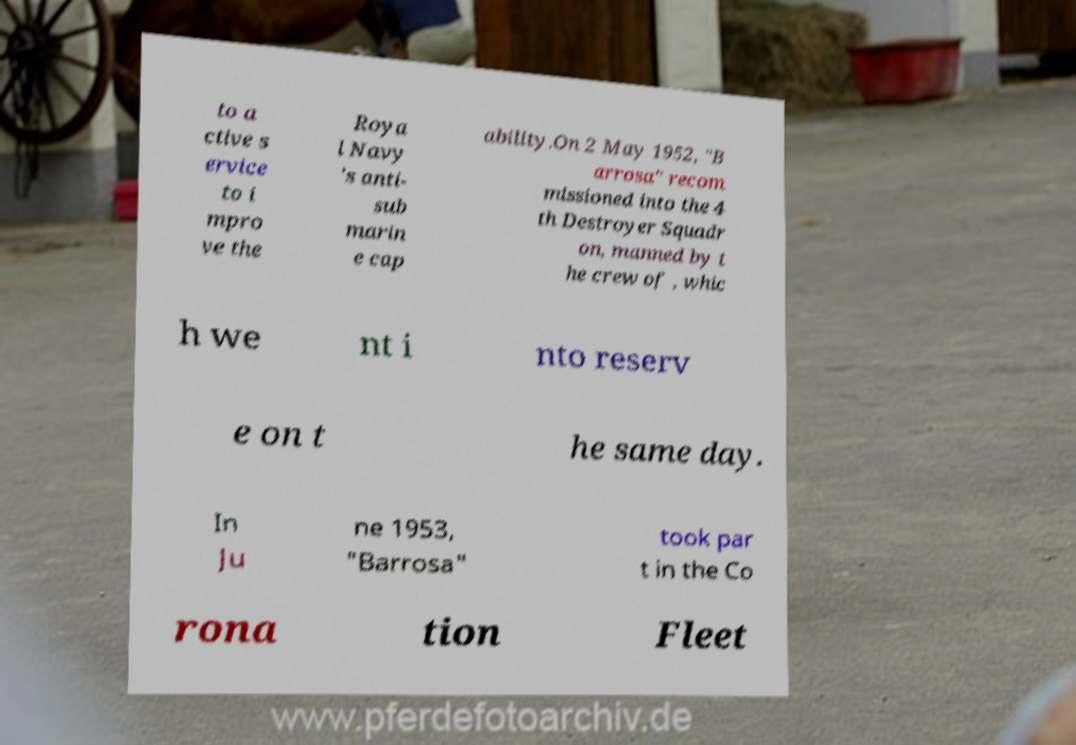Could you assist in decoding the text presented in this image and type it out clearly? to a ctive s ervice to i mpro ve the Roya l Navy 's anti- sub marin e cap ability.On 2 May 1952, "B arrosa" recom missioned into the 4 th Destroyer Squadr on, manned by t he crew of , whic h we nt i nto reserv e on t he same day. In Ju ne 1953, "Barrosa" took par t in the Co rona tion Fleet 